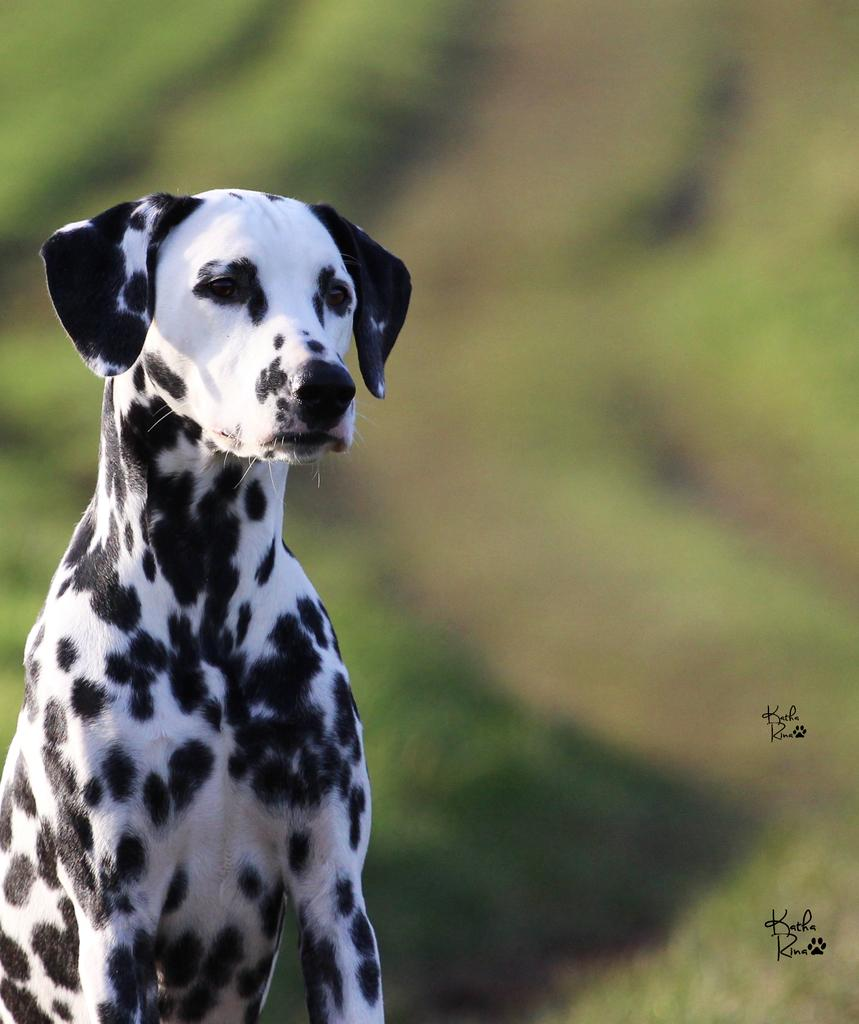What type of animal is in the image? There is a dog in the image. Can you describe the background of the image? The background of the image is blurred. What type of religious symbol can be seen in the image? There is no religious symbol present in the image; it features a dog and a blurred background. How many numbers are visible in the image? There are no numbers visible in the image; it features a dog and a blurred background. 